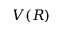<formula> <loc_0><loc_0><loc_500><loc_500>V ( R )</formula> 